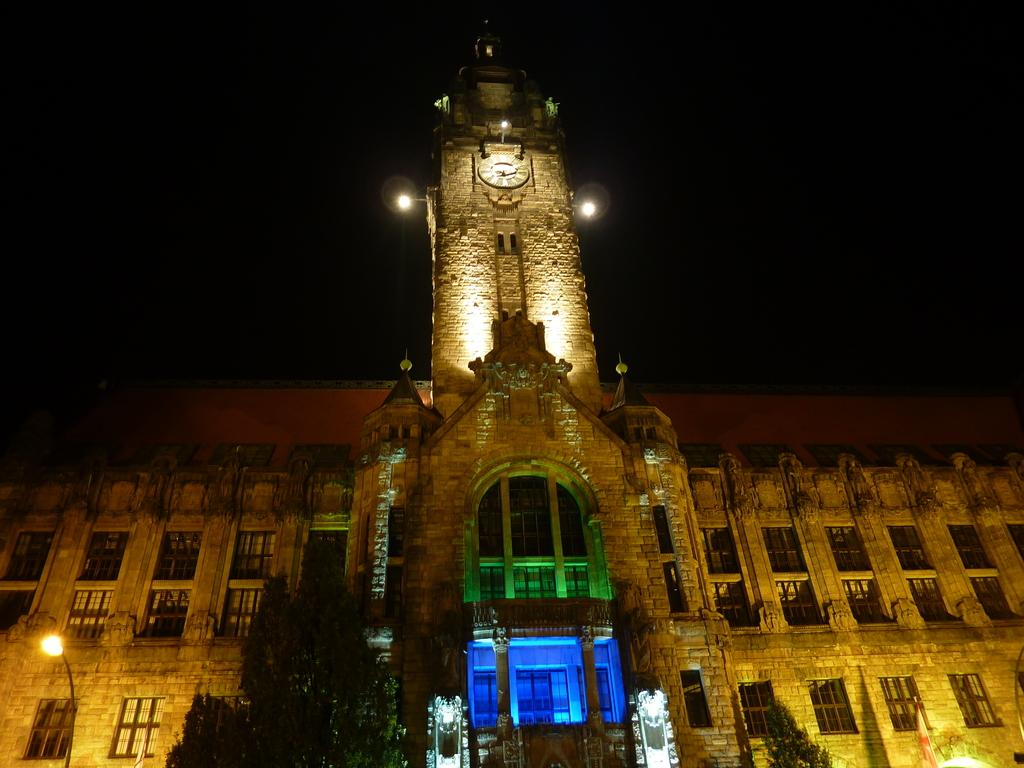What can be seen in the foreground area of the image? In the foreground area of the image, there are trees, a lamp pole, and a building. Can you describe the trees in the foreground area? The trees in the foreground area are visible and are likely part of the landscape or surroundings. What else is present in the foreground area besides the trees? In addition to the trees, there is a lamp pole and a building in the foreground area. How many people are in the crowd gathered around the building in the image? There is no crowd present in the image; it only features trees, a lamp pole, and a building in the foreground area. What decision is being made by the spiders on the lamp pole in the image? There are no spiders present in the image, and therefore no decision-making can be observed. 